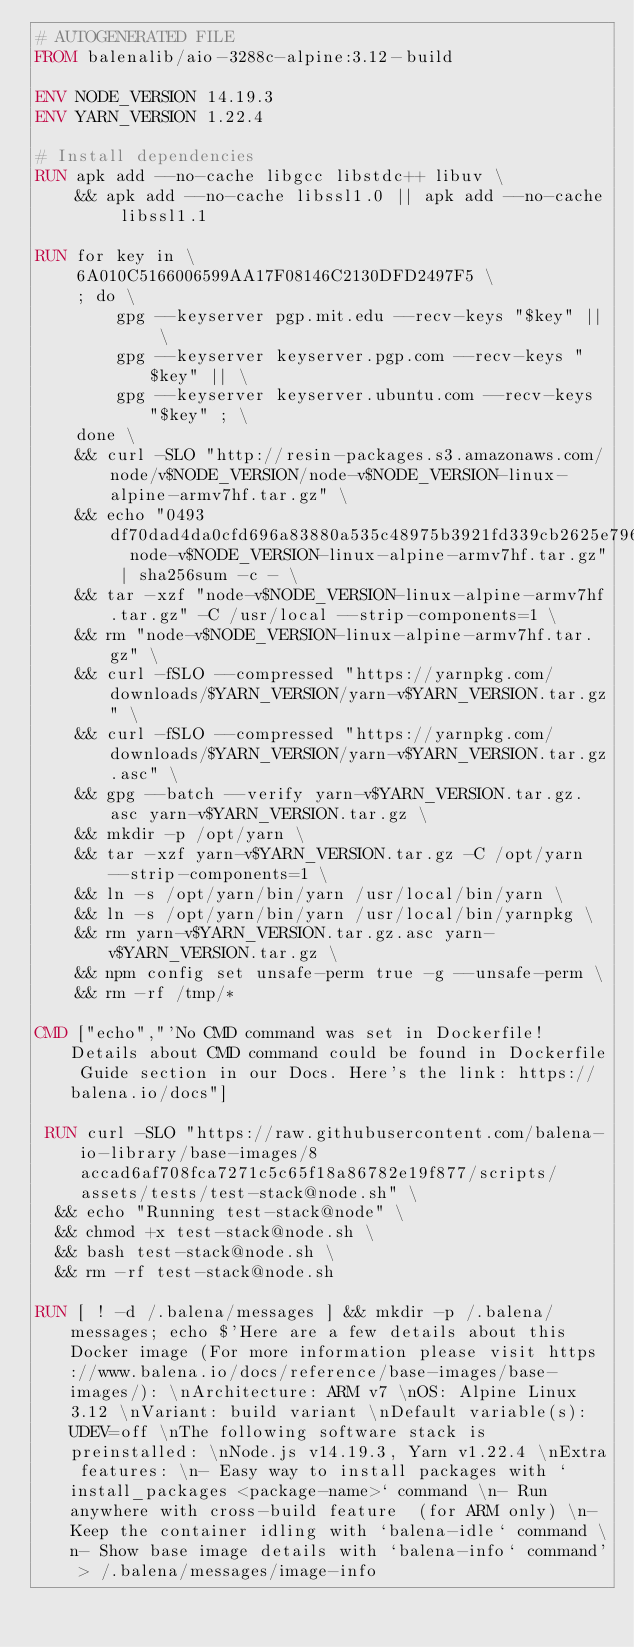Convert code to text. <code><loc_0><loc_0><loc_500><loc_500><_Dockerfile_># AUTOGENERATED FILE
FROM balenalib/aio-3288c-alpine:3.12-build

ENV NODE_VERSION 14.19.3
ENV YARN_VERSION 1.22.4

# Install dependencies
RUN apk add --no-cache libgcc libstdc++ libuv \
	&& apk add --no-cache libssl1.0 || apk add --no-cache libssl1.1

RUN for key in \
	6A010C5166006599AA17F08146C2130DFD2497F5 \
	; do \
		gpg --keyserver pgp.mit.edu --recv-keys "$key" || \
		gpg --keyserver keyserver.pgp.com --recv-keys "$key" || \
		gpg --keyserver keyserver.ubuntu.com --recv-keys "$key" ; \
	done \
	&& curl -SLO "http://resin-packages.s3.amazonaws.com/node/v$NODE_VERSION/node-v$NODE_VERSION-linux-alpine-armv7hf.tar.gz" \
	&& echo "0493df70dad4da0cfd696a83880a535c48975b3921fd339cb2625e796d3c45fe  node-v$NODE_VERSION-linux-alpine-armv7hf.tar.gz" | sha256sum -c - \
	&& tar -xzf "node-v$NODE_VERSION-linux-alpine-armv7hf.tar.gz" -C /usr/local --strip-components=1 \
	&& rm "node-v$NODE_VERSION-linux-alpine-armv7hf.tar.gz" \
	&& curl -fSLO --compressed "https://yarnpkg.com/downloads/$YARN_VERSION/yarn-v$YARN_VERSION.tar.gz" \
	&& curl -fSLO --compressed "https://yarnpkg.com/downloads/$YARN_VERSION/yarn-v$YARN_VERSION.tar.gz.asc" \
	&& gpg --batch --verify yarn-v$YARN_VERSION.tar.gz.asc yarn-v$YARN_VERSION.tar.gz \
	&& mkdir -p /opt/yarn \
	&& tar -xzf yarn-v$YARN_VERSION.tar.gz -C /opt/yarn --strip-components=1 \
	&& ln -s /opt/yarn/bin/yarn /usr/local/bin/yarn \
	&& ln -s /opt/yarn/bin/yarn /usr/local/bin/yarnpkg \
	&& rm yarn-v$YARN_VERSION.tar.gz.asc yarn-v$YARN_VERSION.tar.gz \
	&& npm config set unsafe-perm true -g --unsafe-perm \
	&& rm -rf /tmp/*

CMD ["echo","'No CMD command was set in Dockerfile! Details about CMD command could be found in Dockerfile Guide section in our Docs. Here's the link: https://balena.io/docs"]

 RUN curl -SLO "https://raw.githubusercontent.com/balena-io-library/base-images/8accad6af708fca7271c5c65f18a86782e19f877/scripts/assets/tests/test-stack@node.sh" \
  && echo "Running test-stack@node" \
  && chmod +x test-stack@node.sh \
  && bash test-stack@node.sh \
  && rm -rf test-stack@node.sh 

RUN [ ! -d /.balena/messages ] && mkdir -p /.balena/messages; echo $'Here are a few details about this Docker image (For more information please visit https://www.balena.io/docs/reference/base-images/base-images/): \nArchitecture: ARM v7 \nOS: Alpine Linux 3.12 \nVariant: build variant \nDefault variable(s): UDEV=off \nThe following software stack is preinstalled: \nNode.js v14.19.3, Yarn v1.22.4 \nExtra features: \n- Easy way to install packages with `install_packages <package-name>` command \n- Run anywhere with cross-build feature  (for ARM only) \n- Keep the container idling with `balena-idle` command \n- Show base image details with `balena-info` command' > /.balena/messages/image-info</code> 